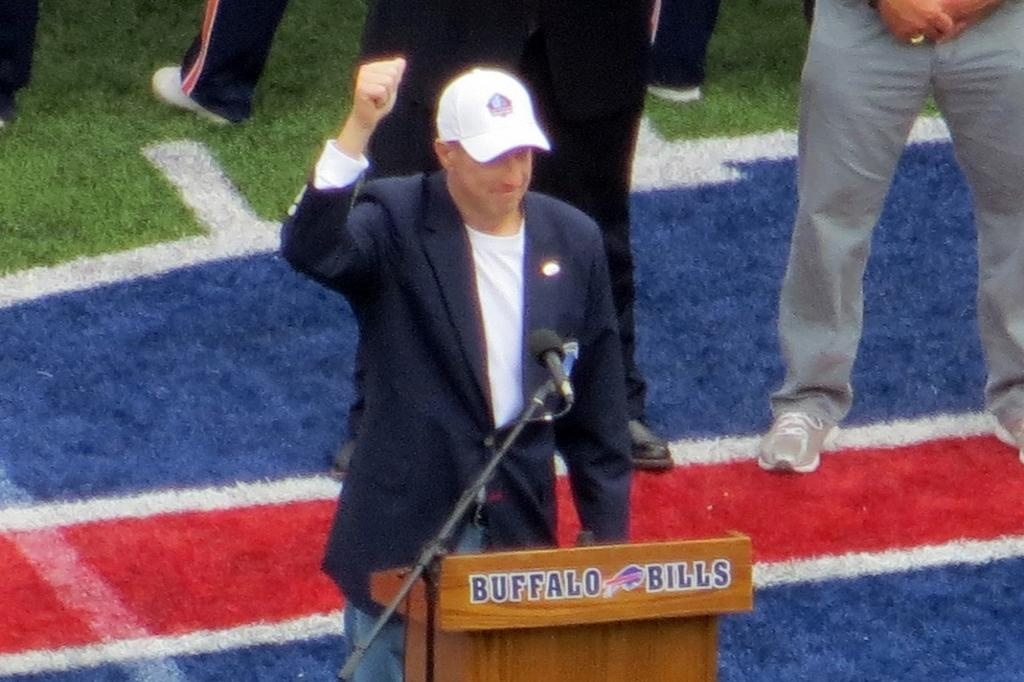How many people are in the image? There is a group of people in the image. What is the position of the people in the image? The people are standing on the ground. Can you describe the clothing of one of the people? One person is wearing a coat and cap. What is located in the foreground of the image? There is a podium in the foreground of the image. What is used for amplifying sound near the podium? A microphone is placed on a stand near the podium. How many snails can be seen crawling on the card in the image? There are no snails or cards present in the image. 